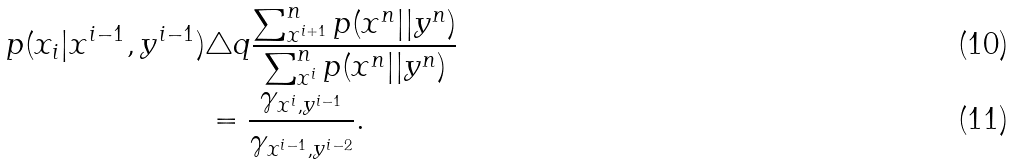Convert formula to latex. <formula><loc_0><loc_0><loc_500><loc_500>p ( x _ { i } | x ^ { i - 1 } , y ^ { i - 1 } ) & \triangle q \frac { \sum _ { x ^ { i + 1 } } ^ { n } p ( x ^ { n } | | y ^ { n } ) } { \sum _ { x ^ { i } } ^ { n } p ( x ^ { n } | | y ^ { n } ) } \\ & = \frac { \gamma _ { x ^ { i } , y ^ { i - 1 } } } { \gamma _ { x ^ { i - 1 } , y ^ { i - 2 } } } .</formula> 